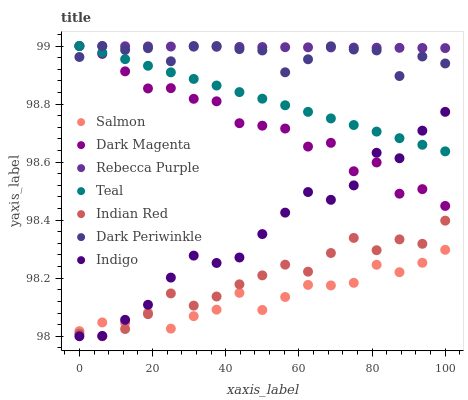Does Salmon have the minimum area under the curve?
Answer yes or no. Yes. Does Rebecca Purple have the maximum area under the curve?
Answer yes or no. Yes. Does Indigo have the minimum area under the curve?
Answer yes or no. No. Does Indigo have the maximum area under the curve?
Answer yes or no. No. Is Rebecca Purple the smoothest?
Answer yes or no. Yes. Is Dark Magenta the roughest?
Answer yes or no. Yes. Is Indigo the smoothest?
Answer yes or no. No. Is Indigo the roughest?
Answer yes or no. No. Does Indigo have the lowest value?
Answer yes or no. Yes. Does Dark Magenta have the lowest value?
Answer yes or no. No. Does Dark Periwinkle have the highest value?
Answer yes or no. Yes. Does Indigo have the highest value?
Answer yes or no. No. Is Indian Red less than Dark Periwinkle?
Answer yes or no. Yes. Is Rebecca Purple greater than Indian Red?
Answer yes or no. Yes. Does Indigo intersect Dark Magenta?
Answer yes or no. Yes. Is Indigo less than Dark Magenta?
Answer yes or no. No. Is Indigo greater than Dark Magenta?
Answer yes or no. No. Does Indian Red intersect Dark Periwinkle?
Answer yes or no. No. 